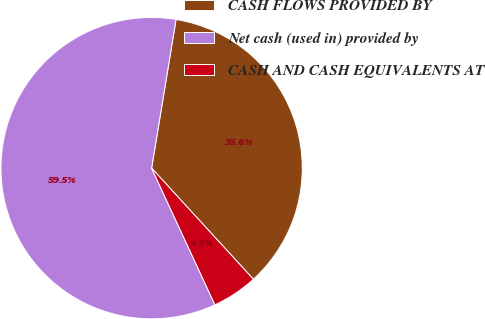Convert chart to OTSL. <chart><loc_0><loc_0><loc_500><loc_500><pie_chart><fcel>CASH FLOWS PROVIDED BY<fcel>Net cash (used in) provided by<fcel>CASH AND CASH EQUIVALENTS AT<nl><fcel>35.61%<fcel>59.5%<fcel>4.9%<nl></chart> 